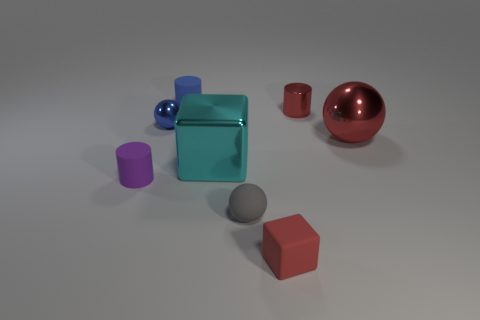Add 1 small rubber spheres. How many objects exist? 9 Subtract all spheres. How many objects are left? 5 Subtract all blue metallic objects. Subtract all gray balls. How many objects are left? 6 Add 3 tiny objects. How many tiny objects are left? 9 Add 4 rubber cylinders. How many rubber cylinders exist? 6 Subtract 0 brown blocks. How many objects are left? 8 